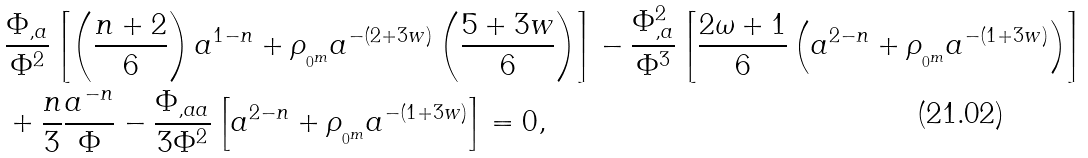<formula> <loc_0><loc_0><loc_500><loc_500>& \frac { \Phi _ { , a } } { \Phi ^ { 2 } } \left [ \left ( \frac { n + 2 } { 6 } \right ) a ^ { 1 - n } + \rho _ { _ { _ { 0 } m } } a ^ { - ( 2 + 3 w ) } \left ( \frac { 5 + 3 w } { 6 } \right ) \right ] - \frac { \Phi _ { , a } ^ { 2 } } { \Phi ^ { 3 } } \left [ \frac { 2 \omega + 1 } { 6 } \left ( a ^ { 2 - n } + \rho _ { _ { _ { 0 } m } } a ^ { - ( 1 + 3 w ) } \right ) \right ] \\ & + \frac { n } { 3 } \frac { a ^ { - n } } { \Phi } - \frac { \Phi _ { , a a } } { 3 \Phi ^ { 2 } } \left [ a ^ { 2 - n } + \rho _ { _ { _ { 0 } m } } a ^ { - ( 1 + 3 w ) } \right ] = 0 ,</formula> 